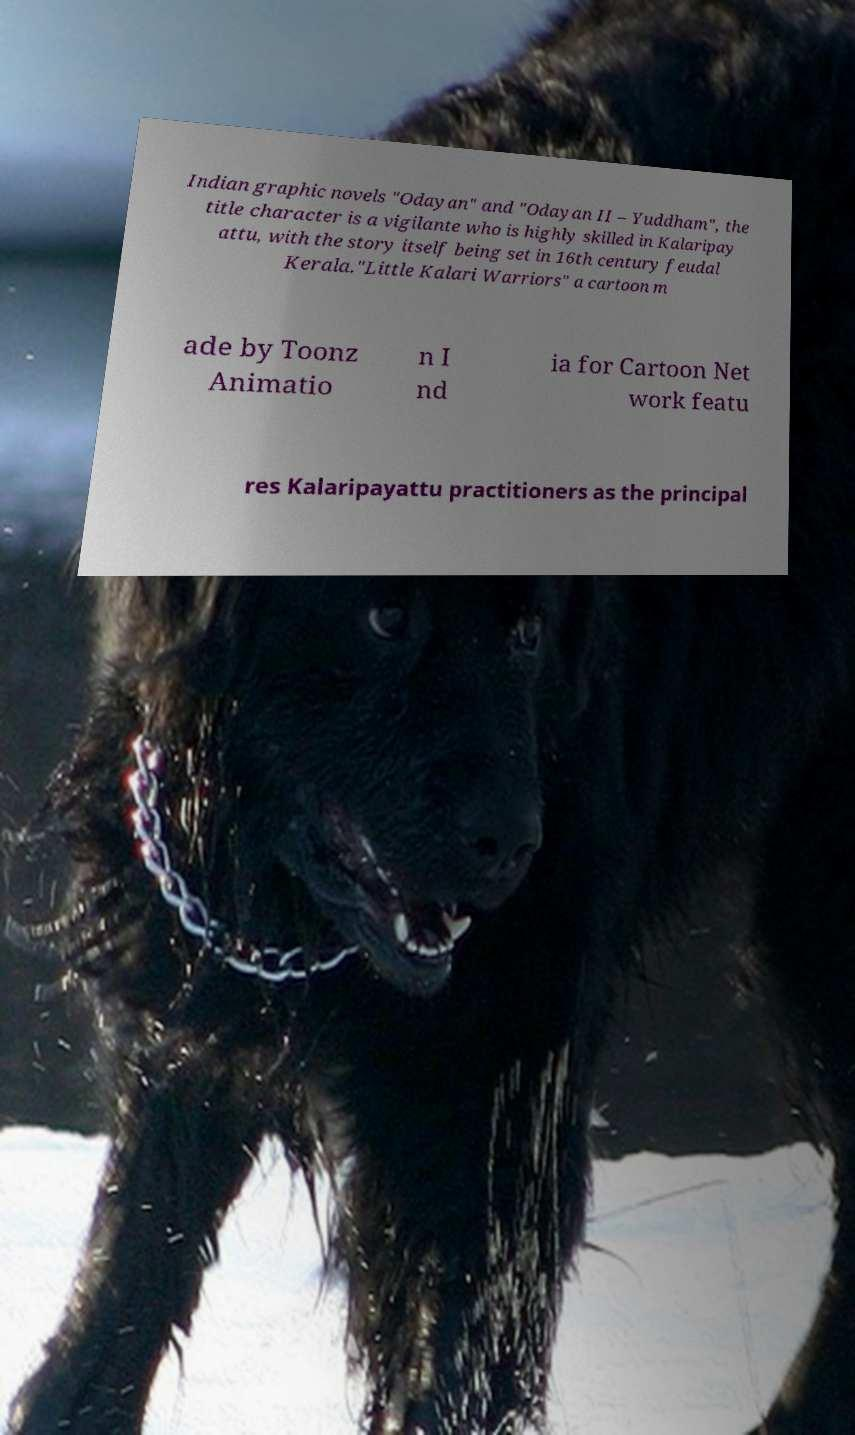Can you read and provide the text displayed in the image?This photo seems to have some interesting text. Can you extract and type it out for me? Indian graphic novels "Odayan" and "Odayan II – Yuddham", the title character is a vigilante who is highly skilled in Kalaripay attu, with the story itself being set in 16th century feudal Kerala."Little Kalari Warriors" a cartoon m ade by Toonz Animatio n I nd ia for Cartoon Net work featu res Kalaripayattu practitioners as the principal 